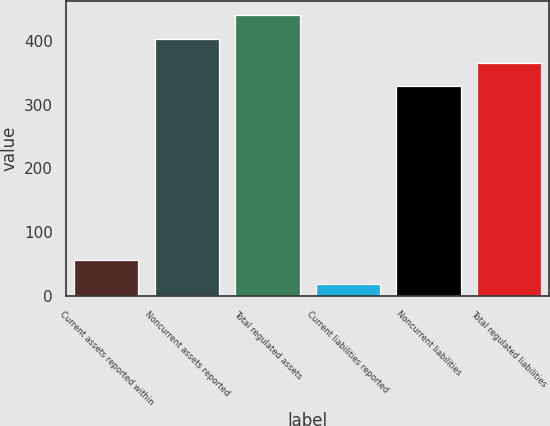Convert chart to OTSL. <chart><loc_0><loc_0><loc_500><loc_500><bar_chart><fcel>Current assets reported within<fcel>Noncurrent assets reported<fcel>Total regulated assets<fcel>Current liabilities reported<fcel>Noncurrent liabilities<fcel>Total regulated liabilities<nl><fcel>56.3<fcel>403.6<fcel>440.9<fcel>19<fcel>329<fcel>366.3<nl></chart> 